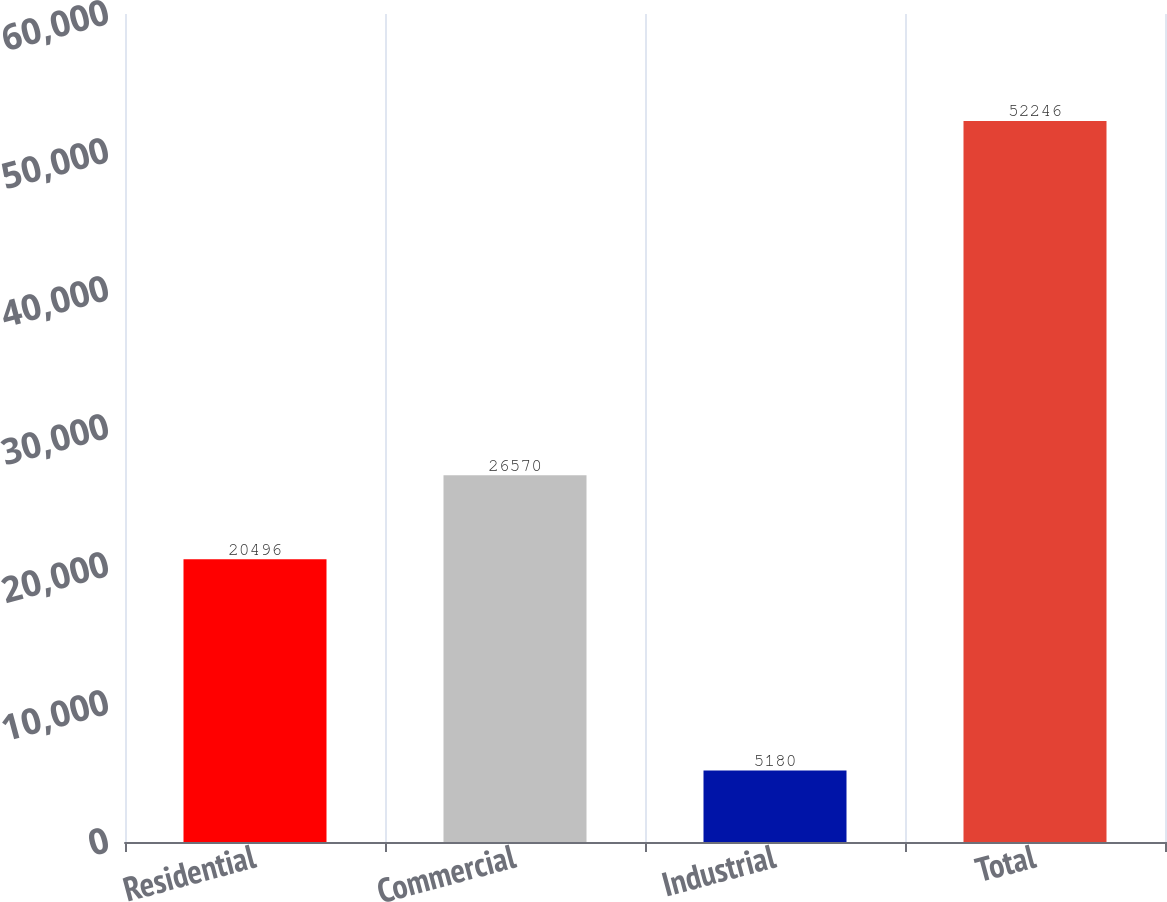<chart> <loc_0><loc_0><loc_500><loc_500><bar_chart><fcel>Residential<fcel>Commercial<fcel>Industrial<fcel>Total<nl><fcel>20496<fcel>26570<fcel>5180<fcel>52246<nl></chart> 